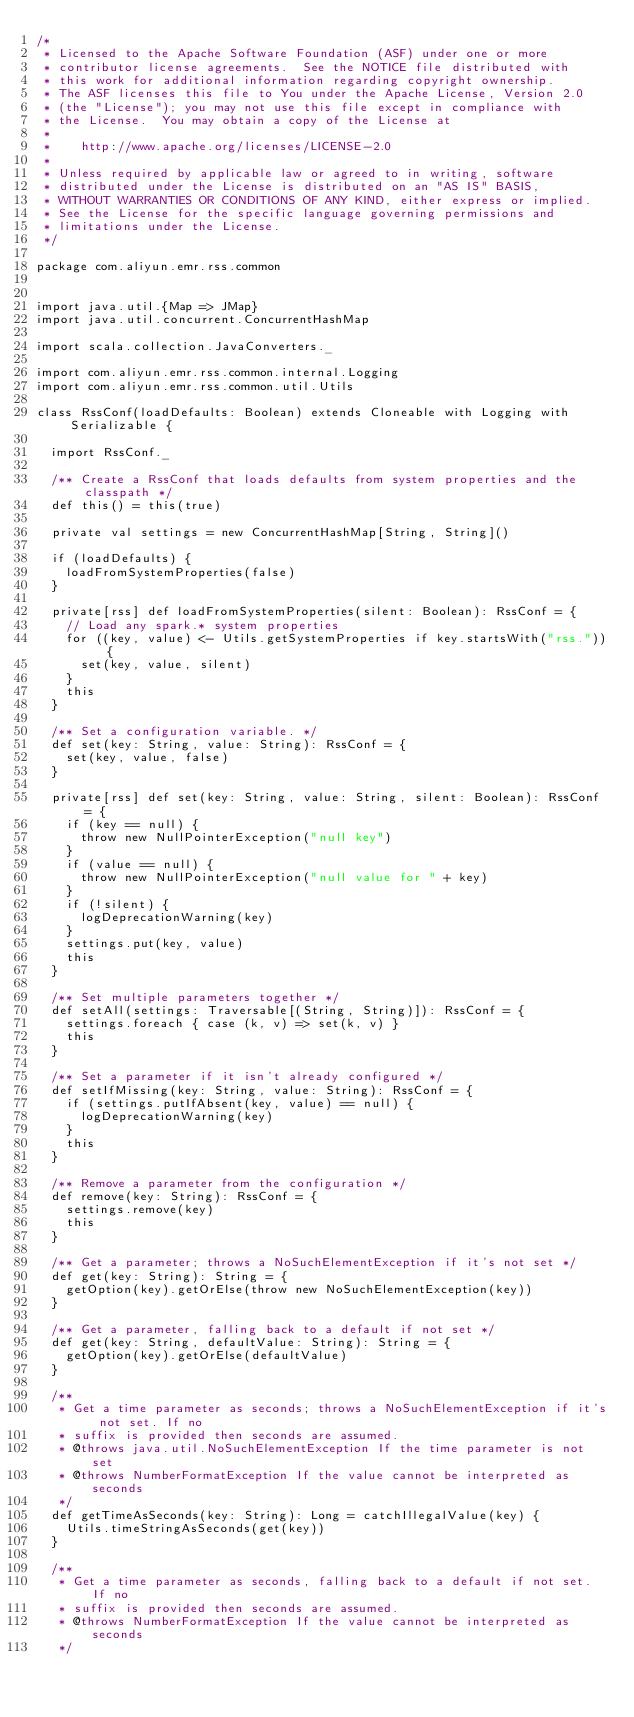<code> <loc_0><loc_0><loc_500><loc_500><_Scala_>/*
 * Licensed to the Apache Software Foundation (ASF) under one or more
 * contributor license agreements.  See the NOTICE file distributed with
 * this work for additional information regarding copyright ownership.
 * The ASF licenses this file to You under the Apache License, Version 2.0
 * (the "License"); you may not use this file except in compliance with
 * the License.  You may obtain a copy of the License at
 *
 *    http://www.apache.org/licenses/LICENSE-2.0
 *
 * Unless required by applicable law or agreed to in writing, software
 * distributed under the License is distributed on an "AS IS" BASIS,
 * WITHOUT WARRANTIES OR CONDITIONS OF ANY KIND, either express or implied.
 * See the License for the specific language governing permissions and
 * limitations under the License.
 */

package com.aliyun.emr.rss.common


import java.util.{Map => JMap}
import java.util.concurrent.ConcurrentHashMap

import scala.collection.JavaConverters._

import com.aliyun.emr.rss.common.internal.Logging
import com.aliyun.emr.rss.common.util.Utils

class RssConf(loadDefaults: Boolean) extends Cloneable with Logging with Serializable {

  import RssConf._

  /** Create a RssConf that loads defaults from system properties and the classpath */
  def this() = this(true)

  private val settings = new ConcurrentHashMap[String, String]()

  if (loadDefaults) {
    loadFromSystemProperties(false)
  }

  private[rss] def loadFromSystemProperties(silent: Boolean): RssConf = {
    // Load any spark.* system properties
    for ((key, value) <- Utils.getSystemProperties if key.startsWith("rss.")) {
      set(key, value, silent)
    }
    this
  }

  /** Set a configuration variable. */
  def set(key: String, value: String): RssConf = {
    set(key, value, false)
  }

  private[rss] def set(key: String, value: String, silent: Boolean): RssConf = {
    if (key == null) {
      throw new NullPointerException("null key")
    }
    if (value == null) {
      throw new NullPointerException("null value for " + key)
    }
    if (!silent) {
      logDeprecationWarning(key)
    }
    settings.put(key, value)
    this
  }

  /** Set multiple parameters together */
  def setAll(settings: Traversable[(String, String)]): RssConf = {
    settings.foreach { case (k, v) => set(k, v) }
    this
  }

  /** Set a parameter if it isn't already configured */
  def setIfMissing(key: String, value: String): RssConf = {
    if (settings.putIfAbsent(key, value) == null) {
      logDeprecationWarning(key)
    }
    this
  }

  /** Remove a parameter from the configuration */
  def remove(key: String): RssConf = {
    settings.remove(key)
    this
  }

  /** Get a parameter; throws a NoSuchElementException if it's not set */
  def get(key: String): String = {
    getOption(key).getOrElse(throw new NoSuchElementException(key))
  }

  /** Get a parameter, falling back to a default if not set */
  def get(key: String, defaultValue: String): String = {
    getOption(key).getOrElse(defaultValue)
  }

  /**
   * Get a time parameter as seconds; throws a NoSuchElementException if it's not set. If no
   * suffix is provided then seconds are assumed.
   * @throws java.util.NoSuchElementException If the time parameter is not set
   * @throws NumberFormatException If the value cannot be interpreted as seconds
   */
  def getTimeAsSeconds(key: String): Long = catchIllegalValue(key) {
    Utils.timeStringAsSeconds(get(key))
  }

  /**
   * Get a time parameter as seconds, falling back to a default if not set. If no
   * suffix is provided then seconds are assumed.
   * @throws NumberFormatException If the value cannot be interpreted as seconds
   */</code> 